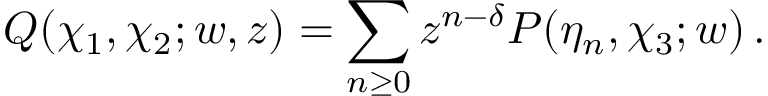Convert formula to latex. <formula><loc_0><loc_0><loc_500><loc_500>Q ( \chi _ { 1 } , \chi _ { 2 } ; w , z ) = \sum _ { n \geq 0 } z ^ { n - \delta } P ( \eta _ { n } , \chi _ { 3 } ; w ) \, .</formula> 